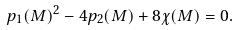Convert formula to latex. <formula><loc_0><loc_0><loc_500><loc_500>p _ { 1 } ( M ) ^ { 2 } - 4 p _ { 2 } ( M ) + 8 \chi ( M ) = 0 .</formula> 